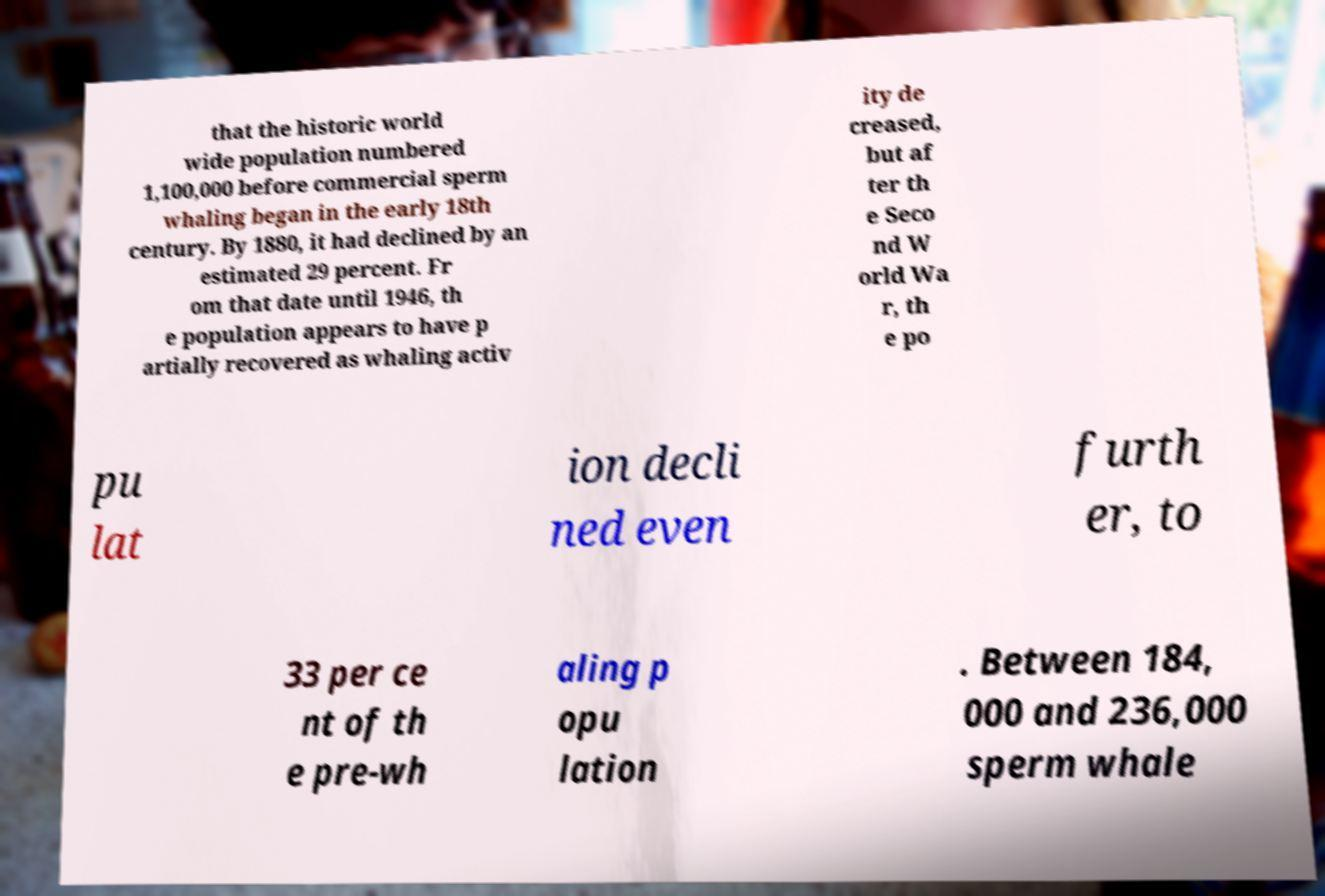Please identify and transcribe the text found in this image. that the historic world wide population numbered 1,100,000 before commercial sperm whaling began in the early 18th century. By 1880, it had declined by an estimated 29 percent. Fr om that date until 1946, th e population appears to have p artially recovered as whaling activ ity de creased, but af ter th e Seco nd W orld Wa r, th e po pu lat ion decli ned even furth er, to 33 per ce nt of th e pre-wh aling p opu lation . Between 184, 000 and 236,000 sperm whale 